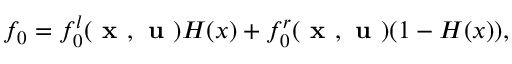Convert formula to latex. <formula><loc_0><loc_0><loc_500><loc_500>f _ { 0 } = f _ { 0 } ^ { l } ( x , u ) H ( x ) + f _ { 0 } ^ { r } ( x , u ) ( 1 - H ( x ) ) ,</formula> 